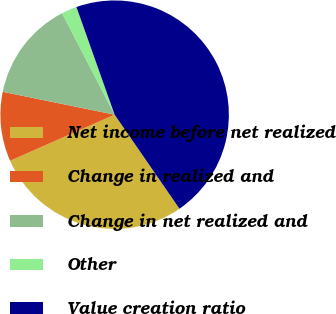Convert chart to OTSL. <chart><loc_0><loc_0><loc_500><loc_500><pie_chart><fcel>Net income before net realized<fcel>Change in realized and<fcel>Change in net realized and<fcel>Other<fcel>Value creation ratio<nl><fcel>28.0%<fcel>9.82%<fcel>14.18%<fcel>2.18%<fcel>45.82%<nl></chart> 